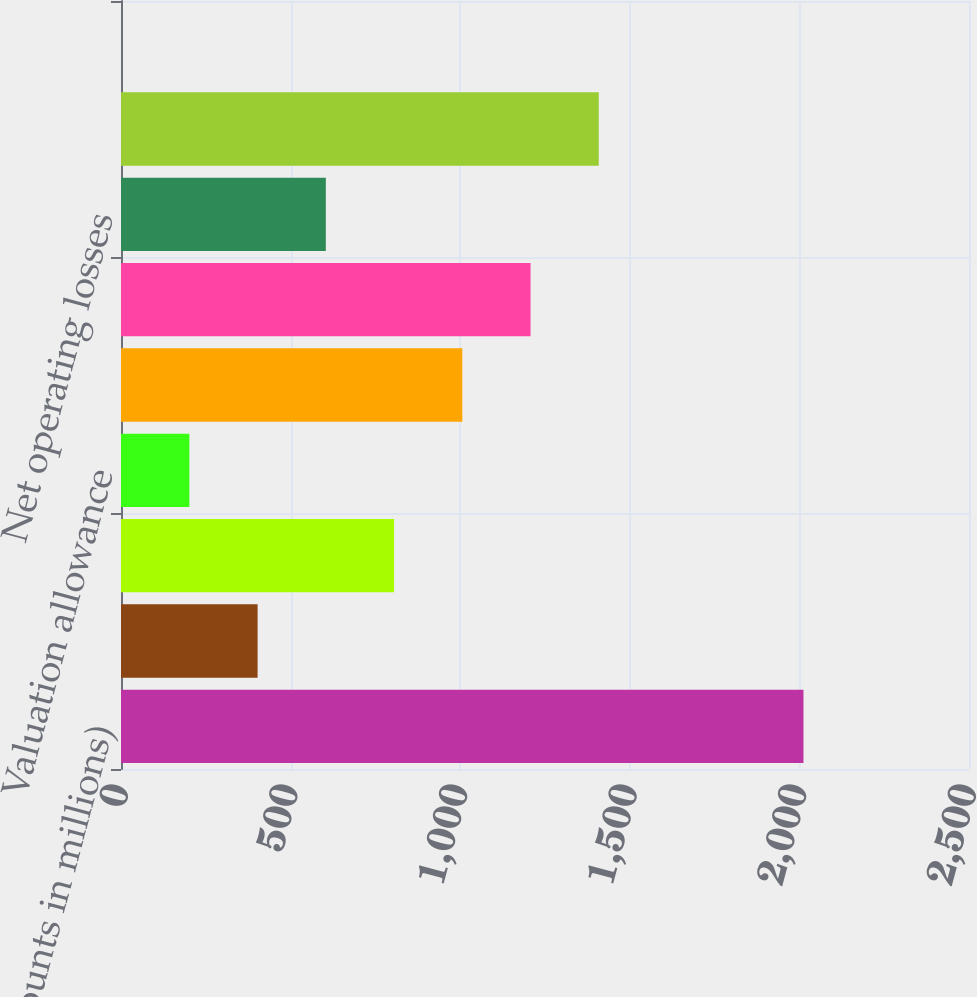<chart> <loc_0><loc_0><loc_500><loc_500><bar_chart><fcel>(Amounts in millions)<fcel>Inventories<fcel>Accruals not currently<fcel>Valuation allowance<fcel>Total current (included in<fcel>Employee benefits<fcel>Net operating losses<fcel>Depreciation and amortization<fcel>SOC securitizations<nl><fcel>2012<fcel>402.72<fcel>805.04<fcel>201.56<fcel>1006.2<fcel>1207.36<fcel>603.88<fcel>1408.52<fcel>0.4<nl></chart> 